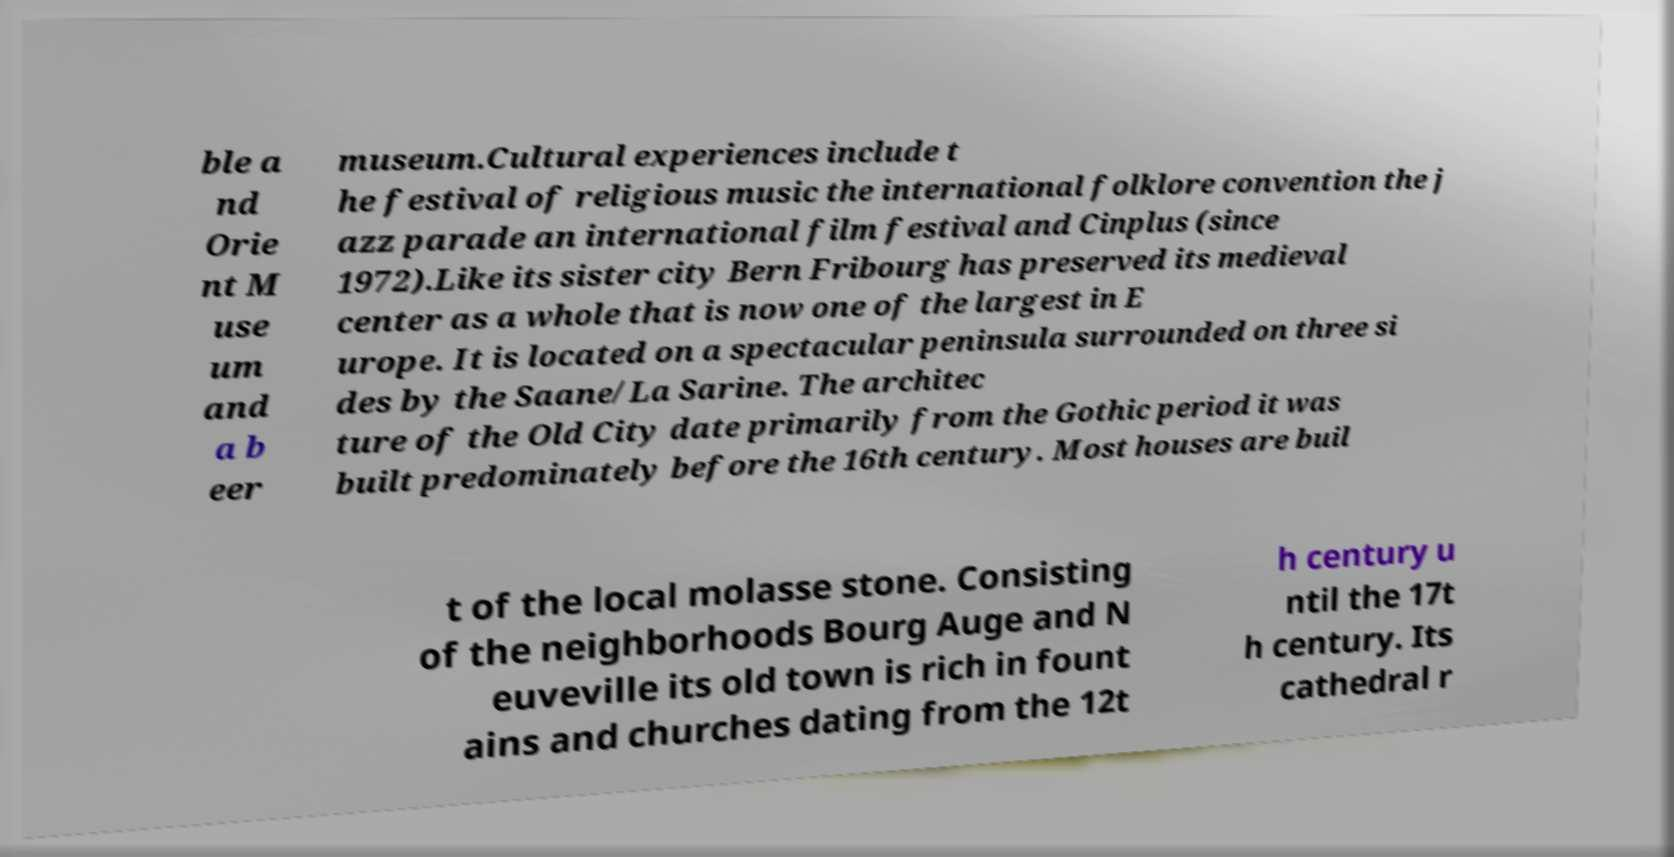There's text embedded in this image that I need extracted. Can you transcribe it verbatim? ble a nd Orie nt M use um and a b eer museum.Cultural experiences include t he festival of religious music the international folklore convention the j azz parade an international film festival and Cinplus (since 1972).Like its sister city Bern Fribourg has preserved its medieval center as a whole that is now one of the largest in E urope. It is located on a spectacular peninsula surrounded on three si des by the Saane/La Sarine. The architec ture of the Old City date primarily from the Gothic period it was built predominately before the 16th century. Most houses are buil t of the local molasse stone. Consisting of the neighborhoods Bourg Auge and N euveville its old town is rich in fount ains and churches dating from the 12t h century u ntil the 17t h century. Its cathedral r 